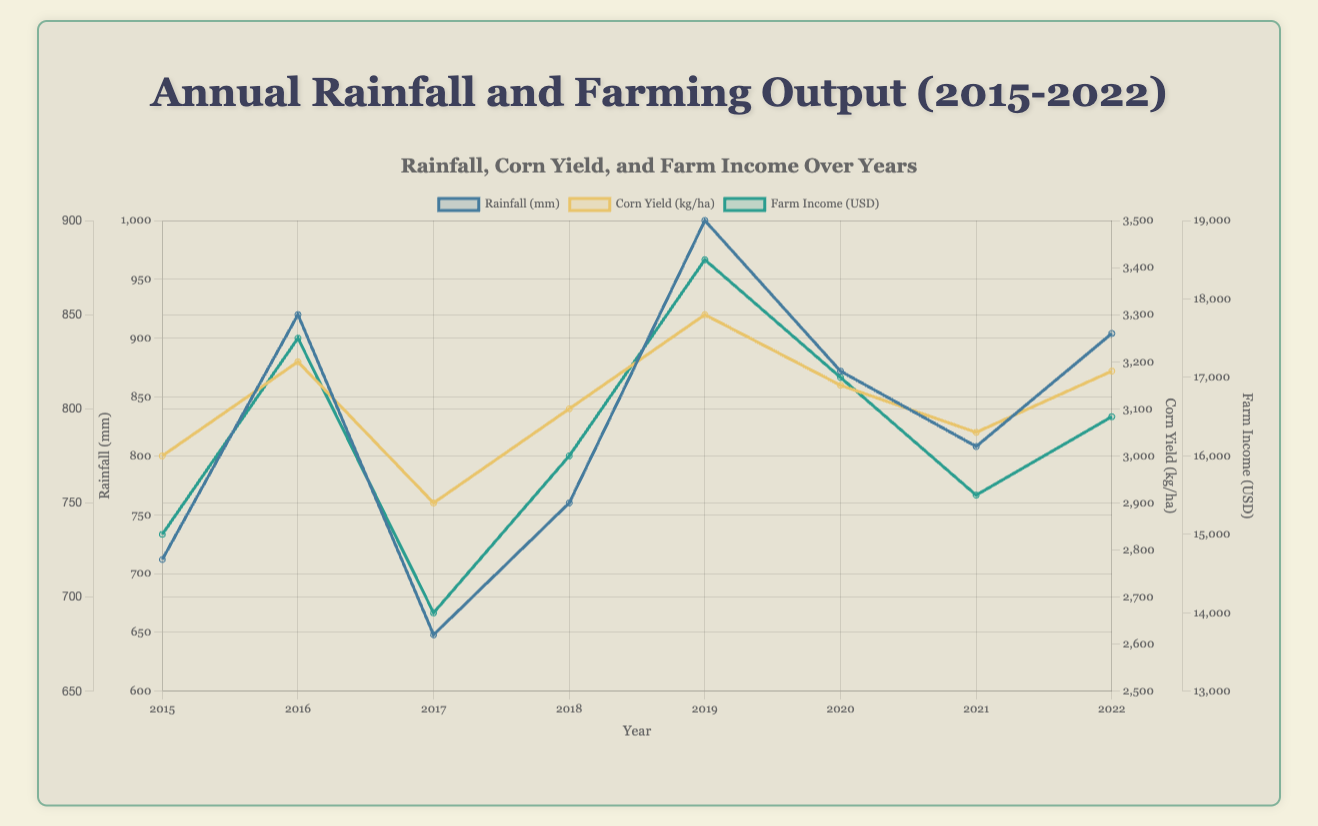How did the rainfall change from 2019 to 2020? The Rainfall in 2019 was 900 mm and in 2020 it decreased to 820 mm. Therefore, the change is 900 - 820 = 80 mm decrease
Answer: 80 mm decrease In which year was the Corn Yield the highest? By observing the Corn Yield data over the years, the highest value is 3300 kg/ha in the year 2019
Answer: 2019 Compare the Farm Income in 2015 and 2022. Which year had a higher income and by how much? In 2015, the Farm Income was 15000 USD and in 2022, it was 16500 USD. Therefore, 2022 had a higher income than 2015 by 16500 - 15000 = 1500 USD
Answer: 2022, by 1500 USD What is the average Corn Yield over the observed years? Sum of Corn Yields from 2015 to 2022 is (3000 + 3200 + 2900 + 3100 + 3300 + 3150 + 3050 + 3180) = 24880 kg/ha. Since there are 8 years, the average is 24880 / 8 = 3110 kg/ha
Answer: 3110 kg/ha Which year experienced both the highest Rainfall and the highest Farm Income? The highest Rainfall is 900 mm in 2019, and the highest Farm Income is also in 2019 with 18500 USD
Answer: 2019 What was the Soy Yield in the year with the lowest rainfall? The lowest Rainfall is 680 mm in 2017, and the Soy Yield in 2017 was 1700 kg/ha
Answer: 1700 kg/ha Is there a visible correlation between Rainfall and Corn Yield over the years? If yes, what is it? Observing the graph, generally, as Rainfall increases, Corn Yield appears to increase as well, suggesting a positive correlation
Answer: Yes, positive correlation Which year had the greatest difference between Wheat Yield and Soy Yield? What was the difference? We calculate the differences for each year and find the greatest: in 2019, Wheat Yield = 2800 kg/ha and Soy Yield = 2100 kg/ha. Difference is 2800 - 2100 = 700 kg/ha, which is the highest
Answer: 2019, 700 kg/ha 